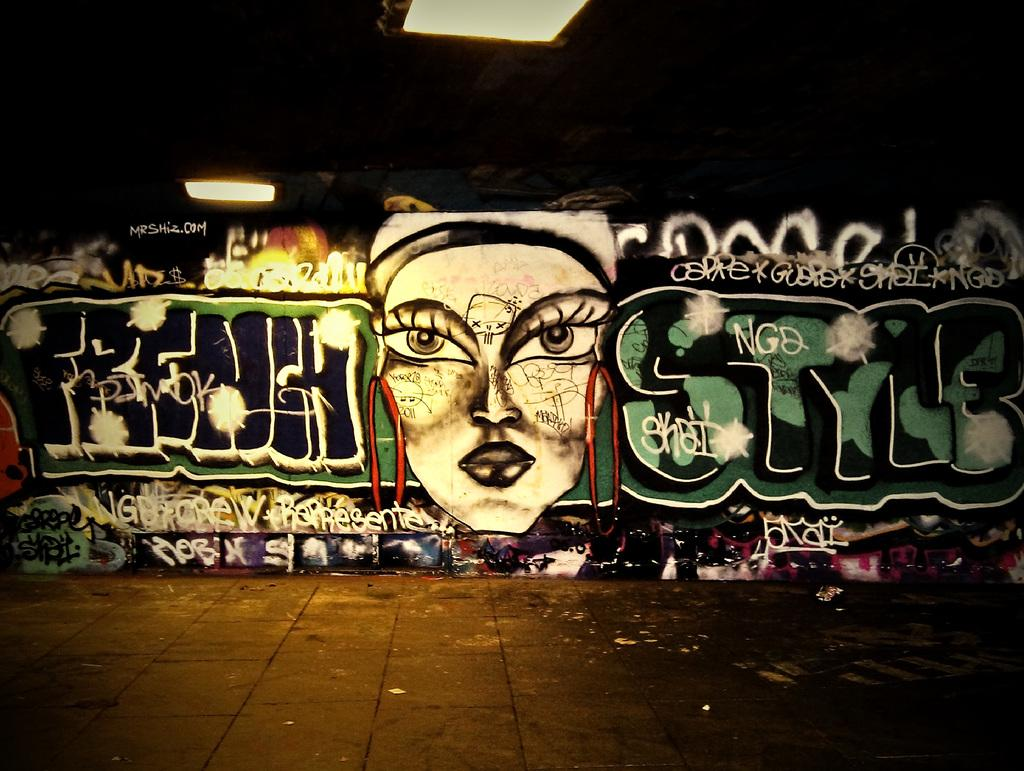What type of surface can be seen in the image? There is a road in the image. What is present on the wall in the image? There is graffiti on a wall in the image. What type of lighting is visible in the image? Ceiling lights are visible in the image. Can you describe a specific area in the image? There is a dark area in the image. How does the yard compare to the graffiti in the image? There is no yard present in the image, so it cannot be compared to the graffiti. Is there a spy observing the scene in the image? There is no indication of a spy or any observer in the image. 